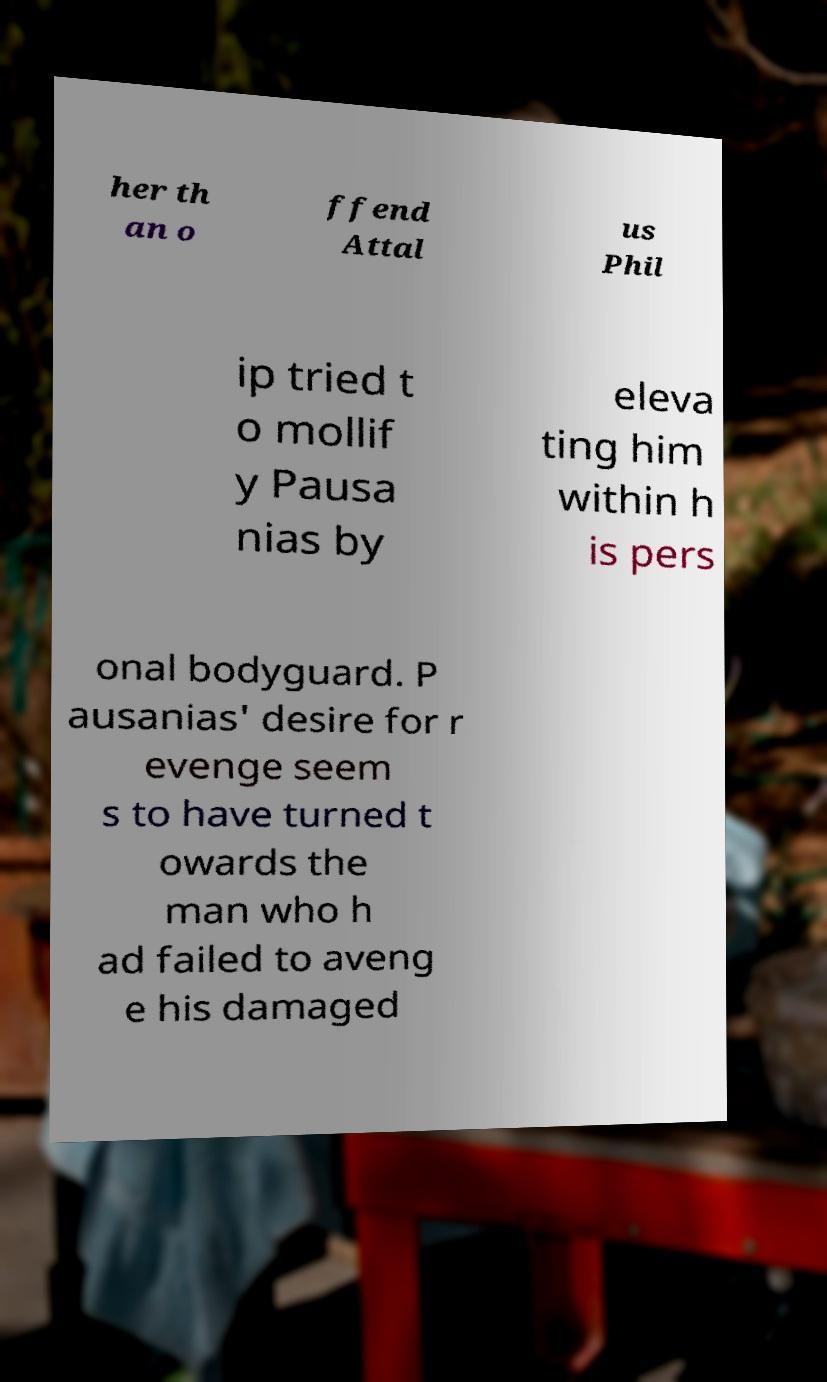What messages or text are displayed in this image? I need them in a readable, typed format. her th an o ffend Attal us Phil ip tried t o mollif y Pausa nias by eleva ting him within h is pers onal bodyguard. P ausanias' desire for r evenge seem s to have turned t owards the man who h ad failed to aveng e his damaged 